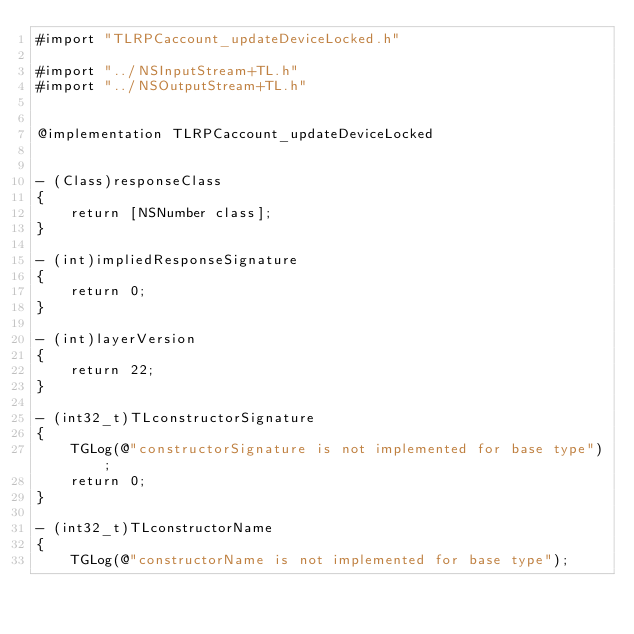Convert code to text. <code><loc_0><loc_0><loc_500><loc_500><_ObjectiveC_>#import "TLRPCaccount_updateDeviceLocked.h"

#import "../NSInputStream+TL.h"
#import "../NSOutputStream+TL.h"


@implementation TLRPCaccount_updateDeviceLocked


- (Class)responseClass
{
    return [NSNumber class];
}

- (int)impliedResponseSignature
{
    return 0;
}

- (int)layerVersion
{
    return 22;
}

- (int32_t)TLconstructorSignature
{
    TGLog(@"constructorSignature is not implemented for base type");
    return 0;
}

- (int32_t)TLconstructorName
{
    TGLog(@"constructorName is not implemented for base type");</code> 